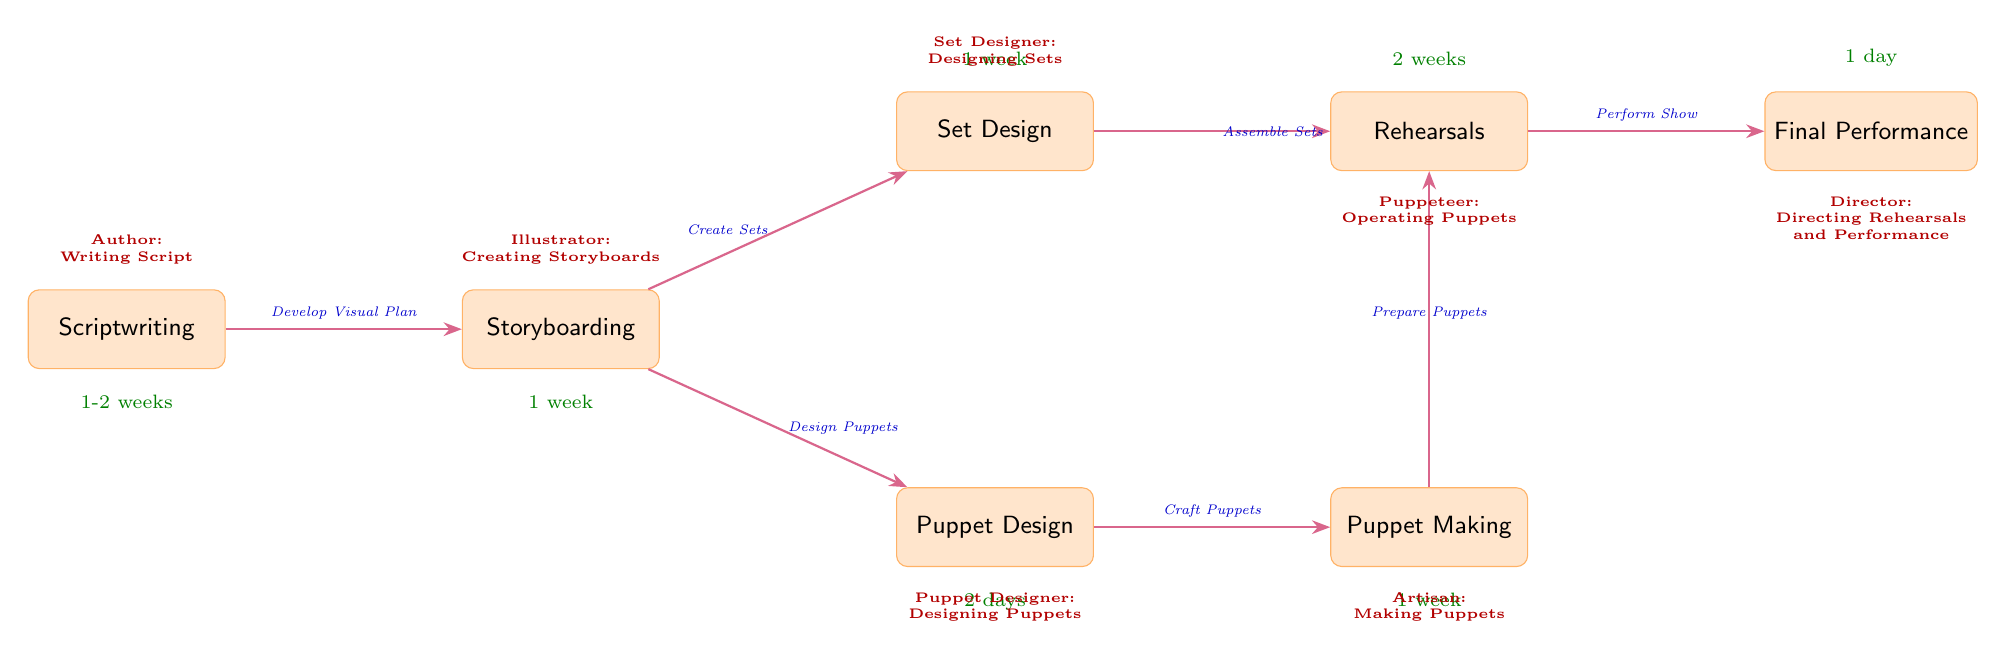What is the first stage in the workflow? The diagram starts with the "Scriptwriting" node. This is the initial step listed at the top of the workflow, indicating that this is where the production process begins.
Answer: Scriptwriting How many weeks does storyboarding take? The timeline for the "Storyboarding" node shows it takes "1 week." This is stated directly beneath the node in the diagram.
Answer: 1 week Which role is responsible for making puppets? The diagram indicates that the "Artisan" is responsible for "Making Puppets," as shown below the "Puppet Making" node.
Answer: Artisan What is the relationship between puppet making and rehearsals? The "Puppet Making" node points to "Rehearsals," indicated by the arrow connecting the two. The label on the arrow states the action as "Prepare Puppets," denoting the progression from making puppets to rehearsing with them.
Answer: Prepare Puppets How long does it take to prepare for the final performance? According to the diagram, the "Rehearsals" section leads to "Final Performance," with the timeline for the "Rehearsals" shown as "2 weeks." The entire preparation before the final performance occurs within this rehearsal timeline.
Answer: 2 weeks What is the role of the Puppeteer? The diagram specifies that the "Puppeteer" is involved in "Operating Puppets," which is described beneath the "Rehearsals" node. This role is crucial during the rehearsals and the final performance.
Answer: Operating Puppets Which design process happens simultaneously with puppet design? The "Set Design" node is connected to "Storyboarding," which occurs concurrently with the "Puppet Design" process as both stem from the "Storyboarding" node. This indicates that during the storyboarding phase, set design can proceed alongside puppet design.
Answer: Set Design What duration is allocated for constructing puppets? The timeline listed beneath the "Puppet Making" node states "1 week." This duration shows how much time is dedicated to creating the puppets after their designs are finalized.
Answer: 1 week What is the final stage of the workflow? The last node in the flow is "Final Performance," which signifies the culmination of all the previous processes and activities. It is the endpoint of the production workflow.
Answer: Final Performance 